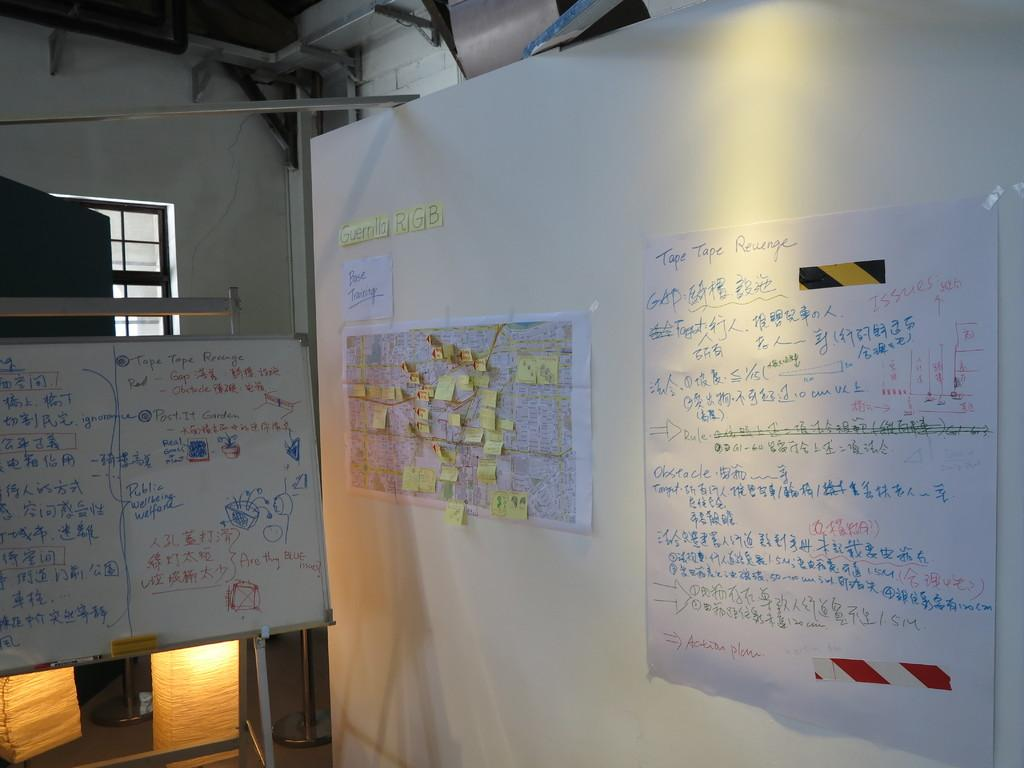What is on the wall in the image? There are posts on a white color wall in the image. What is on the left side of the image? There is a whiteboard on the left side of the image. What can be seen behind the whiteboard? There is a window behind the whiteboard. What type of illumination is visible in the image? Lights are visible in the image. What is behind the window? The wall behind the whiteboard is visible. What object is present in the image that connects the posts? A rod is present in the image. How does the pencil stretch across the room in the image? There is no pencil present in the image, so it cannot stretch across the room. 